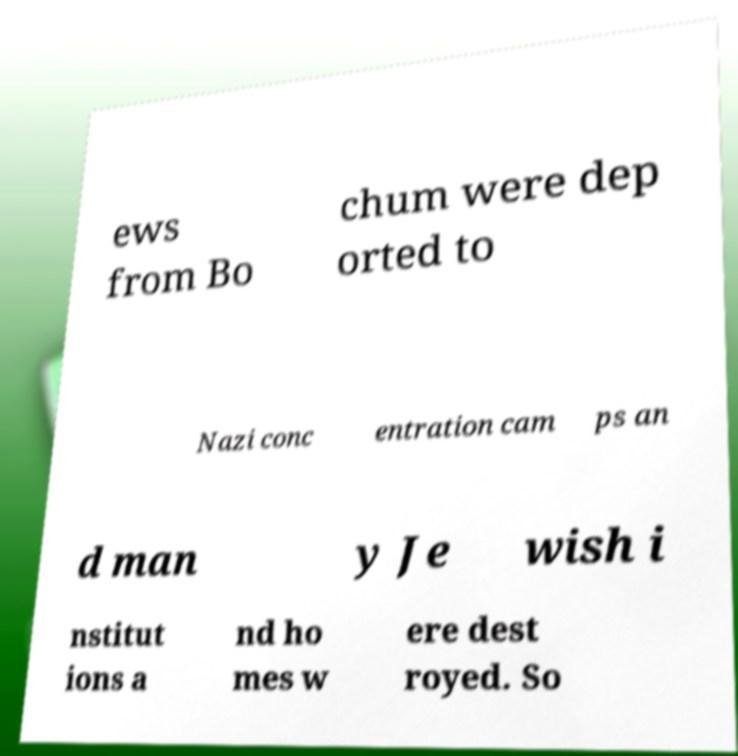Could you extract and type out the text from this image? ews from Bo chum were dep orted to Nazi conc entration cam ps an d man y Je wish i nstitut ions a nd ho mes w ere dest royed. So 